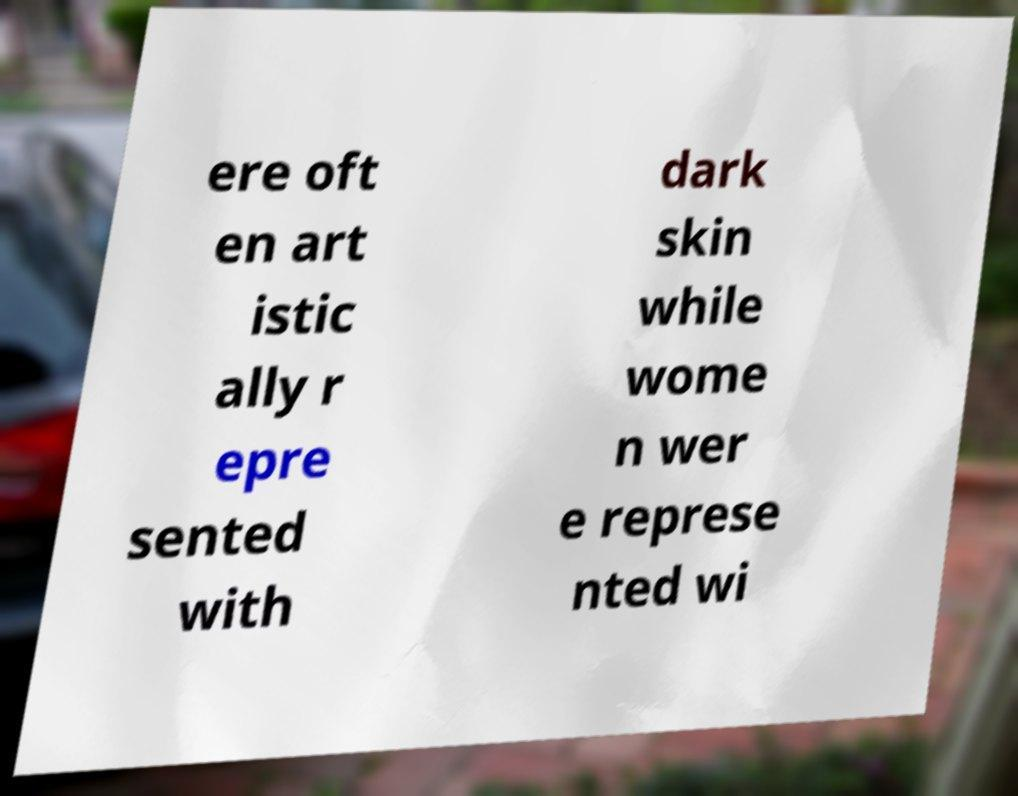For documentation purposes, I need the text within this image transcribed. Could you provide that? ere oft en art istic ally r epre sented with dark skin while wome n wer e represe nted wi 